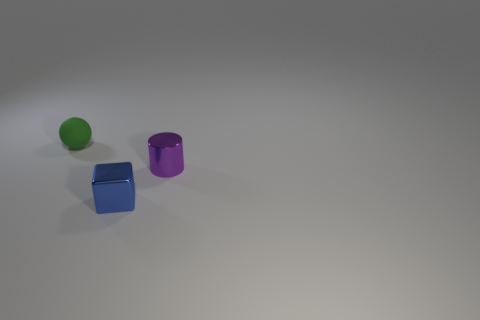What is the object that is to the left of the small purple metallic object and on the right side of the tiny rubber thing made of?
Ensure brevity in your answer.  Metal. There is a tiny shiny thing that is behind the tiny blue metallic block; does it have the same shape as the small shiny object that is in front of the small cylinder?
Your answer should be compact. No. How many things are small shiny things on the right side of the small block or small objects?
Your answer should be compact. 3. Does the green matte object have the same size as the purple shiny object?
Keep it short and to the point. Yes. There is a tiny object that is on the left side of the blue shiny cube; what color is it?
Your answer should be very brief. Green. There is a cube that is made of the same material as the purple cylinder; what is its size?
Your response must be concise. Small. Does the shiny cylinder have the same size as the metallic object that is on the left side of the tiny cylinder?
Provide a short and direct response. Yes. There is a tiny object that is behind the purple metallic object; what is its material?
Offer a very short reply. Rubber. There is a thing that is on the right side of the metallic cube; what number of blue cubes are left of it?
Provide a short and direct response. 1. Is there another rubber object that has the same shape as the tiny green thing?
Your response must be concise. No. 